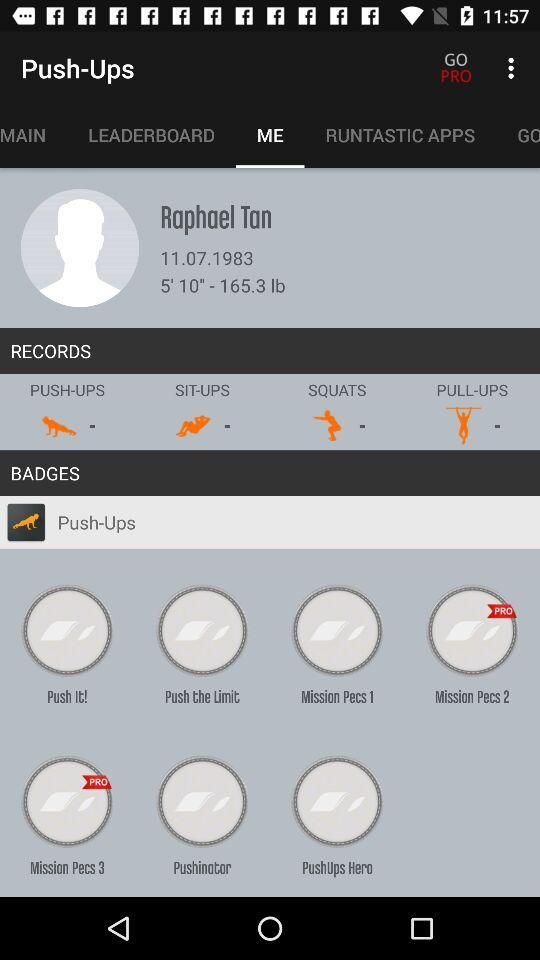What is the name of the user? The name of the user is Raphael Tan. 